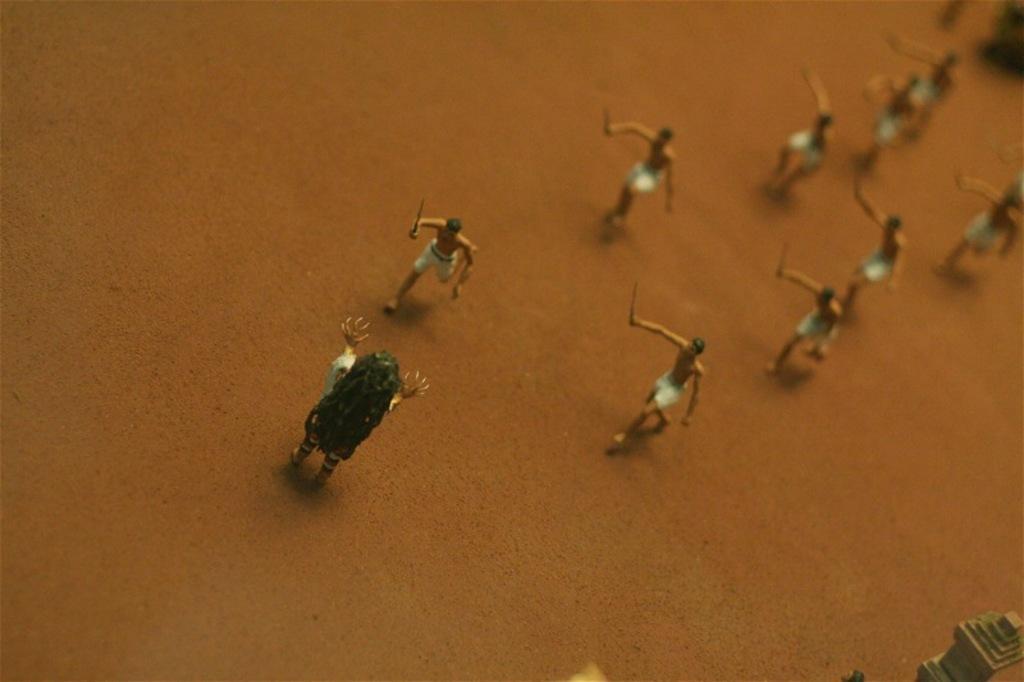How would you summarize this image in a sentence or two? In this image I see few miniature persons which are on the ground. 